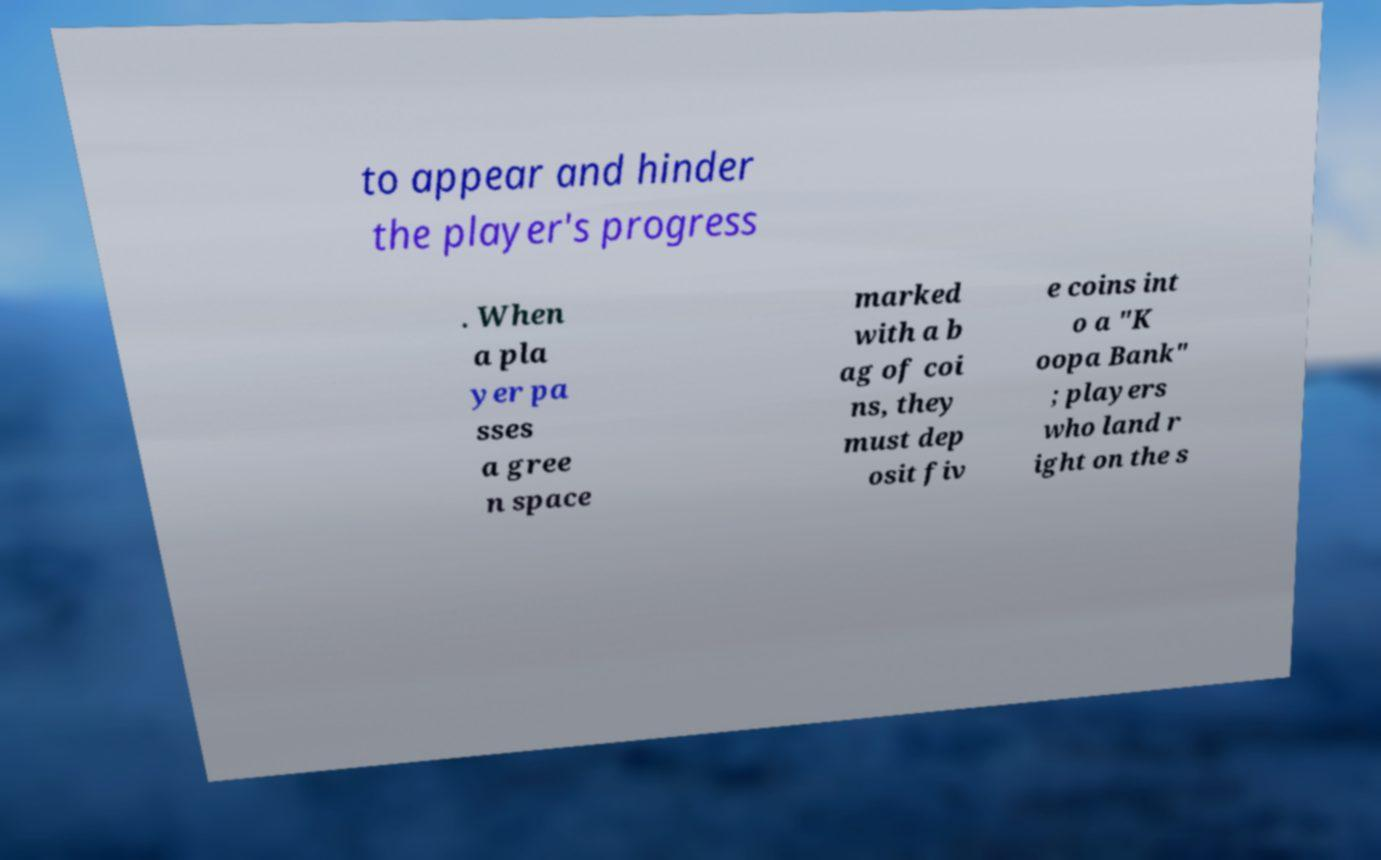For documentation purposes, I need the text within this image transcribed. Could you provide that? to appear and hinder the player's progress . When a pla yer pa sses a gree n space marked with a b ag of coi ns, they must dep osit fiv e coins int o a "K oopa Bank" ; players who land r ight on the s 